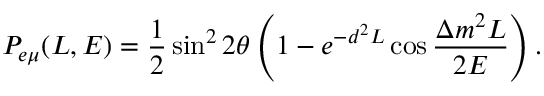<formula> <loc_0><loc_0><loc_500><loc_500>P _ { e \mu } ( L , E ) = \frac { 1 } { 2 } \sin ^ { 2 } 2 \theta \left ( 1 - e ^ { - d ^ { 2 } L } \cos \frac { \Delta m ^ { 2 } L } { 2 E } \right ) .</formula> 